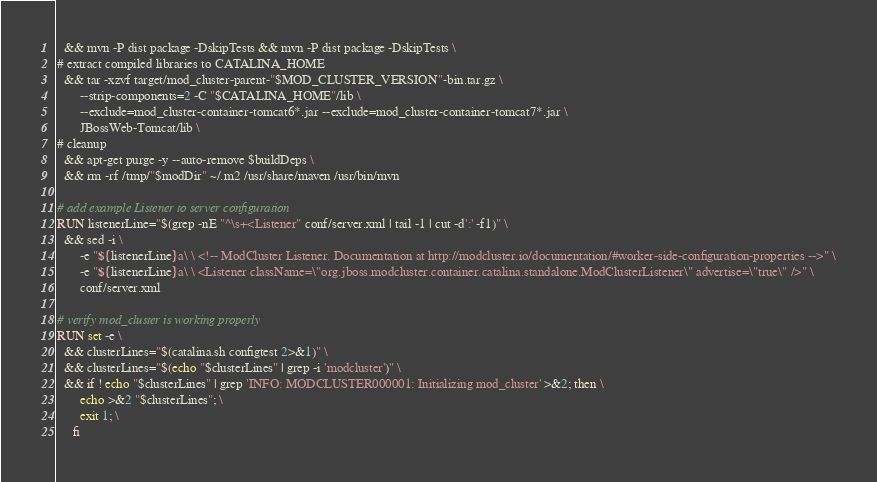Convert code to text. <code><loc_0><loc_0><loc_500><loc_500><_Dockerfile_>  && mvn -P dist package -DskipTests && mvn -P dist package -DskipTests \
# extract compiled libraries to CATALINA_HOME
  && tar -xzvf target/mod_cluster-parent-"$MOD_CLUSTER_VERSION"-bin.tar.gz \
       --strip-components=2 -C "$CATALINA_HOME"/lib \
       --exclude=mod_cluster-container-tomcat6*.jar --exclude=mod_cluster-container-tomcat7*.jar \
       JBossWeb-Tomcat/lib \
# cleanup
  && apt-get purge -y --auto-remove $buildDeps \
  && rm -rf /tmp/"$modDir" ~/.m2 /usr/share/maven /usr/bin/mvn

# add example Listener to server configuration
RUN listenerLine="$(grep -nE "^\s+<Listener" conf/server.xml | tail -1 | cut -d':' -f1)" \
  && sed -i \
       -e "${listenerLine}a\ \ <!-- ModCluster Listener. Documentation at http://modcluster.io/documentation/#worker-side-configuration-properties -->" \
       -e "${listenerLine}a\ \ <Listener className=\"org.jboss.modcluster.container.catalina.standalone.ModClusterListener\" advertise=\"true\" />" \
       conf/server.xml

# verify mod_cluster is working properly
RUN set -e \
  && clusterLines="$(catalina.sh configtest 2>&1)" \
  && clusterLines="$(echo "$clusterLines" | grep -i 'modcluster')" \
  && if ! echo "$clusterLines" | grep 'INFO: MODCLUSTER000001: Initializing mod_cluster' >&2; then \
       echo >&2 "$clusterLines"; \
       exit 1; \
     fi
</code> 